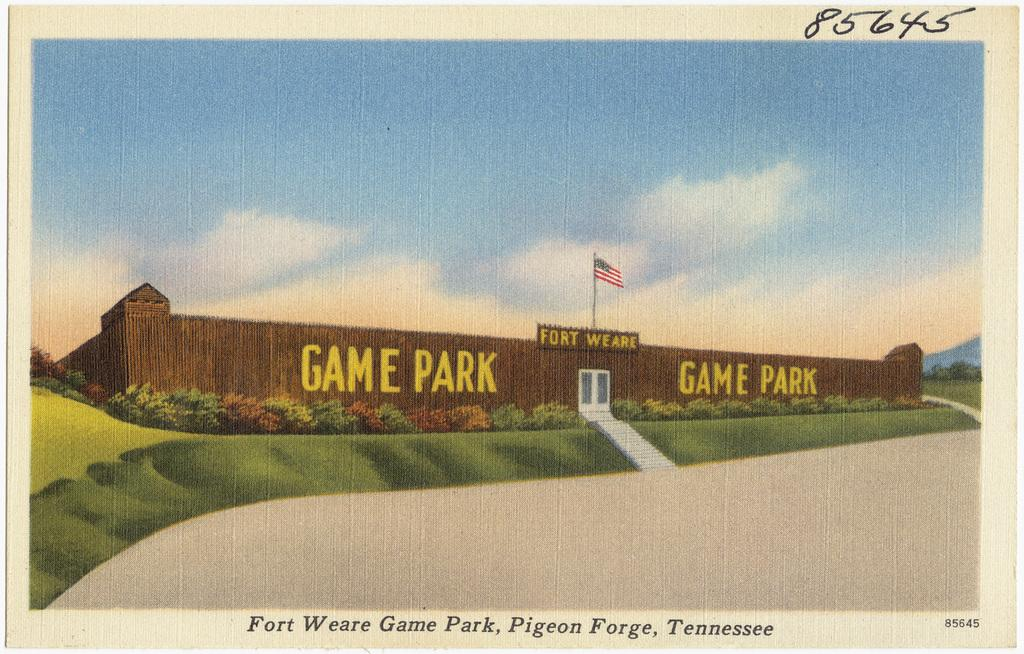Provide a one-sentence caption for the provided image. A card featuring a drawing of the Fort Weare Game Park. 